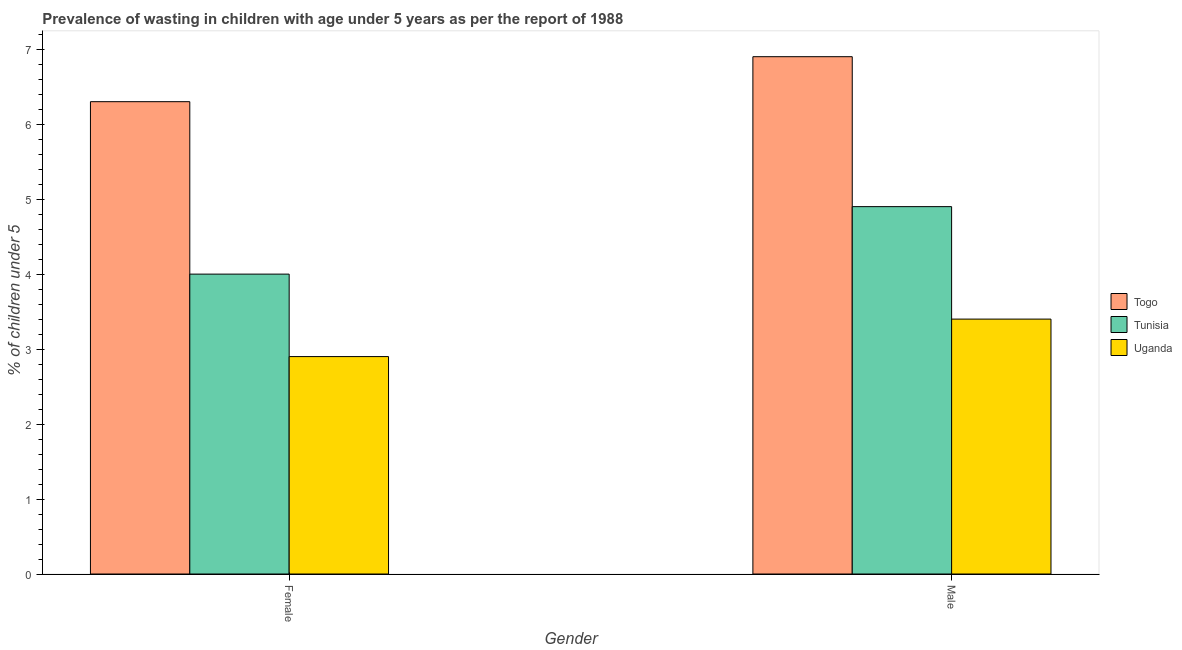How many different coloured bars are there?
Give a very brief answer. 3. How many groups of bars are there?
Offer a very short reply. 2. Are the number of bars per tick equal to the number of legend labels?
Your response must be concise. Yes. Are the number of bars on each tick of the X-axis equal?
Provide a short and direct response. Yes. How many bars are there on the 2nd tick from the right?
Your answer should be very brief. 3. What is the label of the 1st group of bars from the left?
Your answer should be very brief. Female. What is the percentage of undernourished female children in Uganda?
Keep it short and to the point. 2.9. Across all countries, what is the maximum percentage of undernourished male children?
Make the answer very short. 6.9. Across all countries, what is the minimum percentage of undernourished male children?
Offer a terse response. 3.4. In which country was the percentage of undernourished female children maximum?
Your answer should be compact. Togo. In which country was the percentage of undernourished male children minimum?
Keep it short and to the point. Uganda. What is the total percentage of undernourished female children in the graph?
Make the answer very short. 13.2. What is the difference between the percentage of undernourished female children in Tunisia and that in Uganda?
Your answer should be compact. 1.1. What is the difference between the percentage of undernourished female children in Togo and the percentage of undernourished male children in Uganda?
Provide a succinct answer. 2.9. What is the average percentage of undernourished female children per country?
Ensure brevity in your answer.  4.4. What is the difference between the percentage of undernourished male children and percentage of undernourished female children in Tunisia?
Your answer should be very brief. 0.9. In how many countries, is the percentage of undernourished male children greater than 3 %?
Your answer should be very brief. 3. What is the ratio of the percentage of undernourished male children in Tunisia to that in Uganda?
Give a very brief answer. 1.44. Is the percentage of undernourished female children in Uganda less than that in Togo?
Offer a terse response. Yes. What does the 3rd bar from the left in Female represents?
Keep it short and to the point. Uganda. What does the 2nd bar from the right in Female represents?
Offer a terse response. Tunisia. Are the values on the major ticks of Y-axis written in scientific E-notation?
Give a very brief answer. No. Does the graph contain any zero values?
Provide a short and direct response. No. Does the graph contain grids?
Keep it short and to the point. No. Where does the legend appear in the graph?
Offer a very short reply. Center right. How many legend labels are there?
Make the answer very short. 3. How are the legend labels stacked?
Offer a terse response. Vertical. What is the title of the graph?
Ensure brevity in your answer.  Prevalence of wasting in children with age under 5 years as per the report of 1988. What is the label or title of the X-axis?
Ensure brevity in your answer.  Gender. What is the label or title of the Y-axis?
Give a very brief answer.  % of children under 5. What is the  % of children under 5 of Togo in Female?
Make the answer very short. 6.3. What is the  % of children under 5 of Uganda in Female?
Give a very brief answer. 2.9. What is the  % of children under 5 in Togo in Male?
Give a very brief answer. 6.9. What is the  % of children under 5 of Tunisia in Male?
Make the answer very short. 4.9. What is the  % of children under 5 in Uganda in Male?
Provide a short and direct response. 3.4. Across all Gender, what is the maximum  % of children under 5 in Togo?
Offer a very short reply. 6.9. Across all Gender, what is the maximum  % of children under 5 of Tunisia?
Offer a very short reply. 4.9. Across all Gender, what is the maximum  % of children under 5 in Uganda?
Your response must be concise. 3.4. Across all Gender, what is the minimum  % of children under 5 in Togo?
Give a very brief answer. 6.3. Across all Gender, what is the minimum  % of children under 5 of Uganda?
Your response must be concise. 2.9. What is the total  % of children under 5 of Togo in the graph?
Offer a terse response. 13.2. What is the total  % of children under 5 in Uganda in the graph?
Your response must be concise. 6.3. What is the difference between the  % of children under 5 in Tunisia in Female and that in Male?
Your answer should be compact. -0.9. What is the difference between the  % of children under 5 in Uganda in Female and that in Male?
Provide a short and direct response. -0.5. What is the difference between the  % of children under 5 in Togo in Female and the  % of children under 5 in Tunisia in Male?
Give a very brief answer. 1.4. What is the average  % of children under 5 of Tunisia per Gender?
Provide a succinct answer. 4.45. What is the average  % of children under 5 in Uganda per Gender?
Make the answer very short. 3.15. What is the difference between the  % of children under 5 of Togo and  % of children under 5 of Uganda in Female?
Keep it short and to the point. 3.4. What is the difference between the  % of children under 5 of Togo and  % of children under 5 of Uganda in Male?
Your answer should be very brief. 3.5. What is the ratio of the  % of children under 5 of Togo in Female to that in Male?
Keep it short and to the point. 0.91. What is the ratio of the  % of children under 5 in Tunisia in Female to that in Male?
Keep it short and to the point. 0.82. What is the ratio of the  % of children under 5 of Uganda in Female to that in Male?
Your response must be concise. 0.85. What is the difference between the highest and the second highest  % of children under 5 in Tunisia?
Your response must be concise. 0.9. What is the difference between the highest and the second highest  % of children under 5 of Uganda?
Offer a terse response. 0.5. What is the difference between the highest and the lowest  % of children under 5 of Togo?
Ensure brevity in your answer.  0.6. 